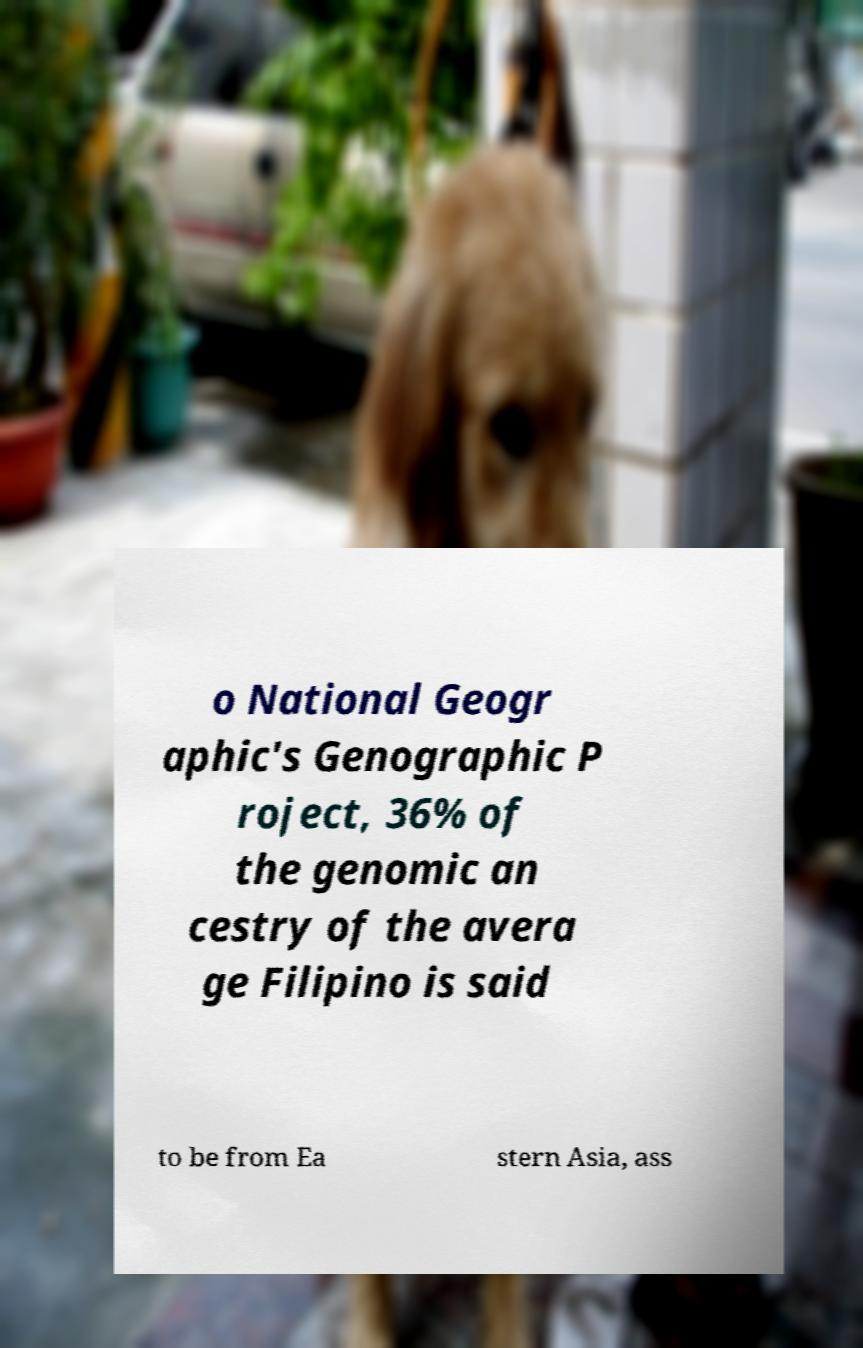For documentation purposes, I need the text within this image transcribed. Could you provide that? o National Geogr aphic's Genographic P roject, 36% of the genomic an cestry of the avera ge Filipino is said to be from Ea stern Asia, ass 